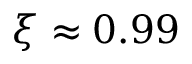<formula> <loc_0><loc_0><loc_500><loc_500>\xi \approx 0 . 9 9</formula> 